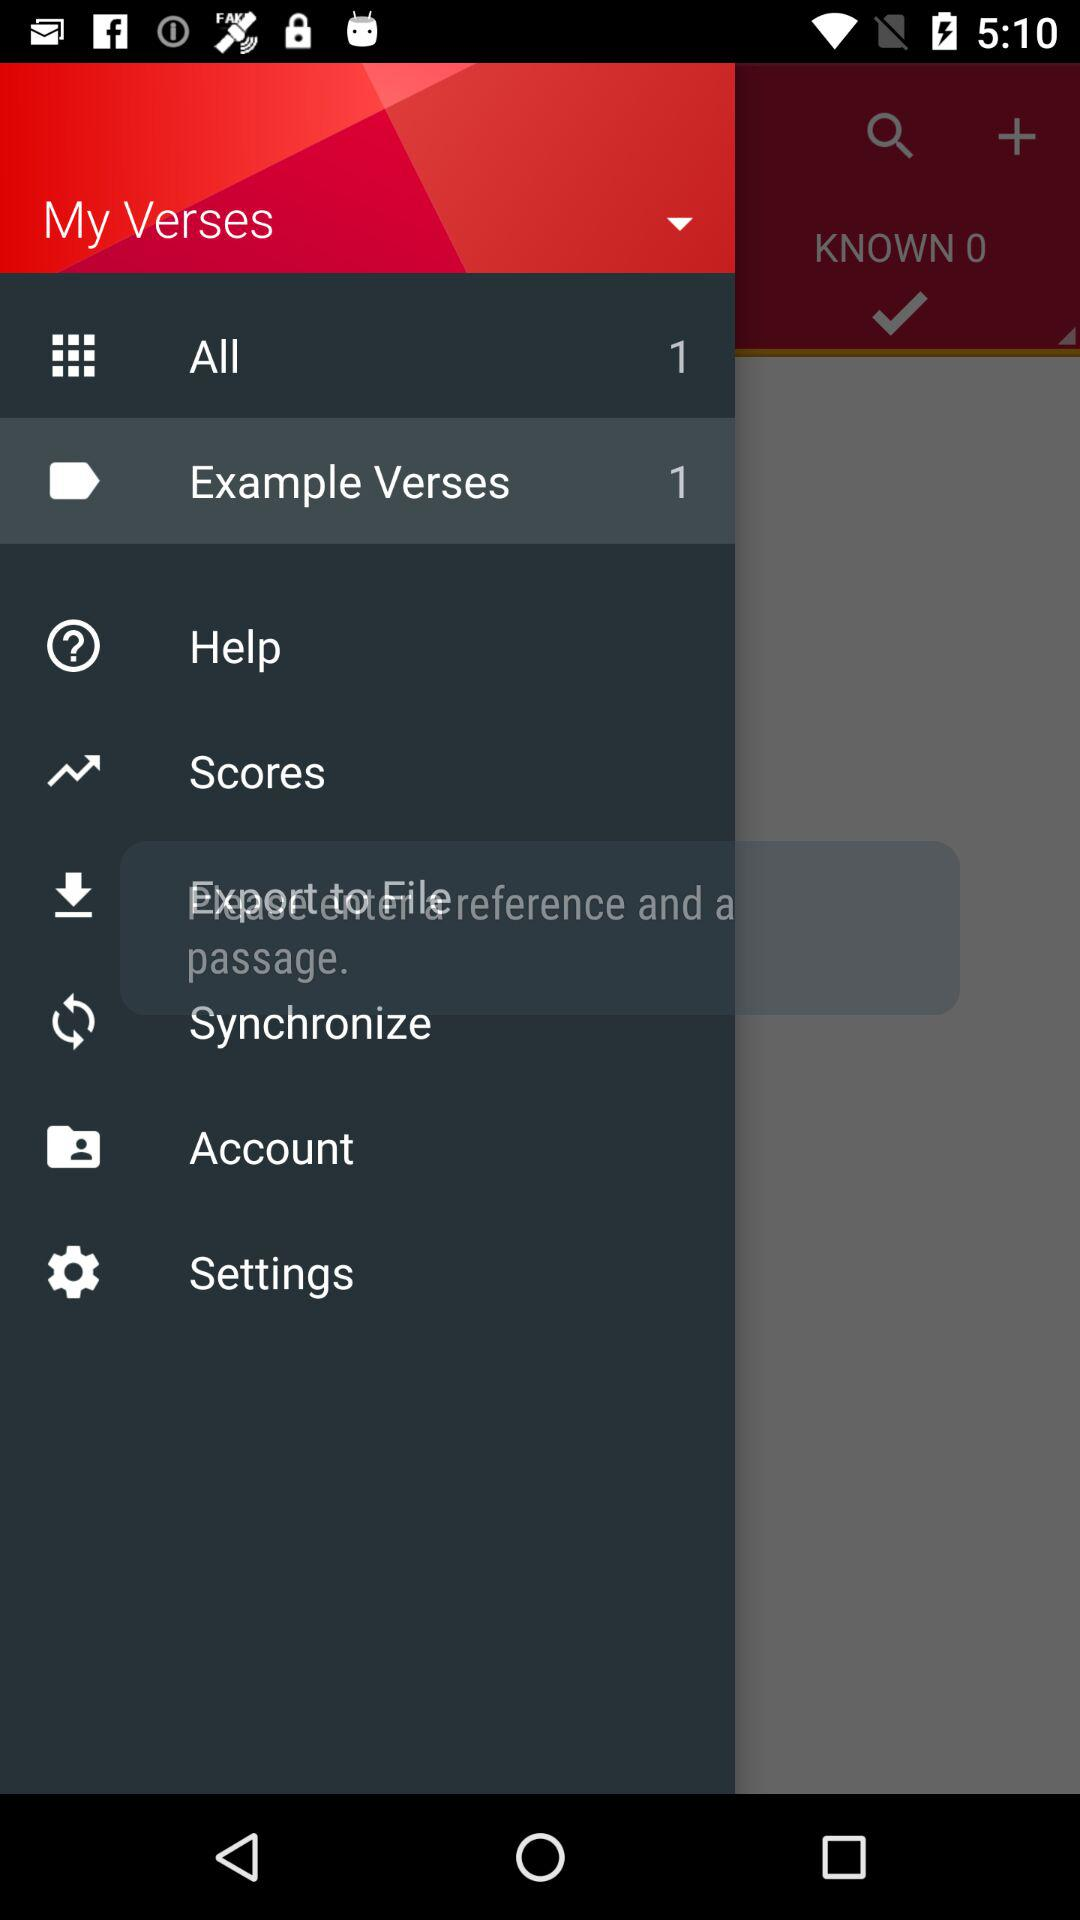What is the number of "All" in My Verses? The number of "All" is 1. 